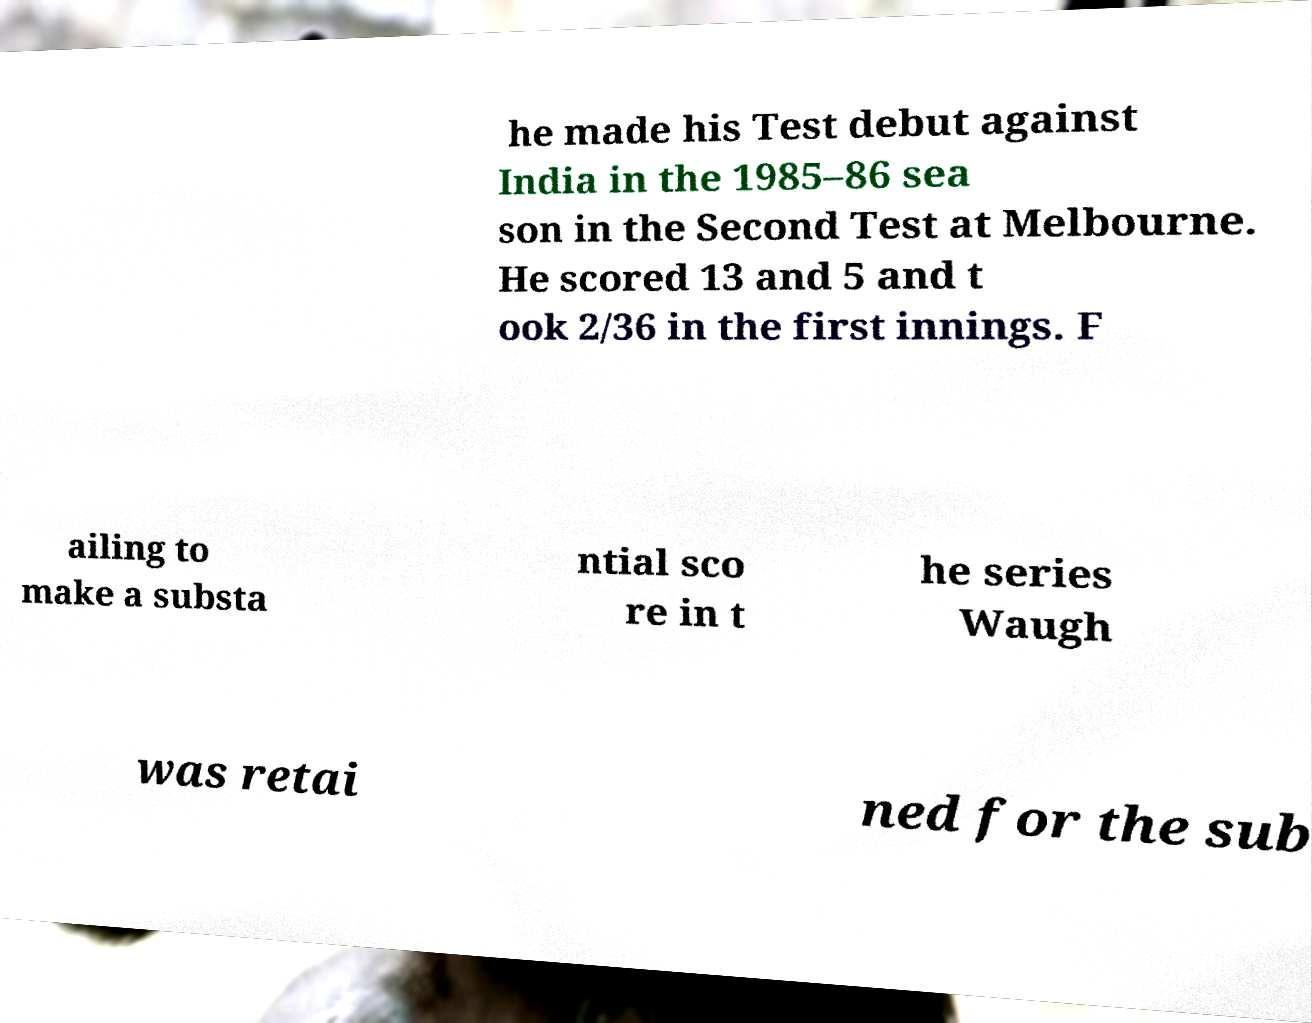For documentation purposes, I need the text within this image transcribed. Could you provide that? he made his Test debut against India in the 1985–86 sea son in the Second Test at Melbourne. He scored 13 and 5 and t ook 2/36 in the first innings. F ailing to make a substa ntial sco re in t he series Waugh was retai ned for the sub 